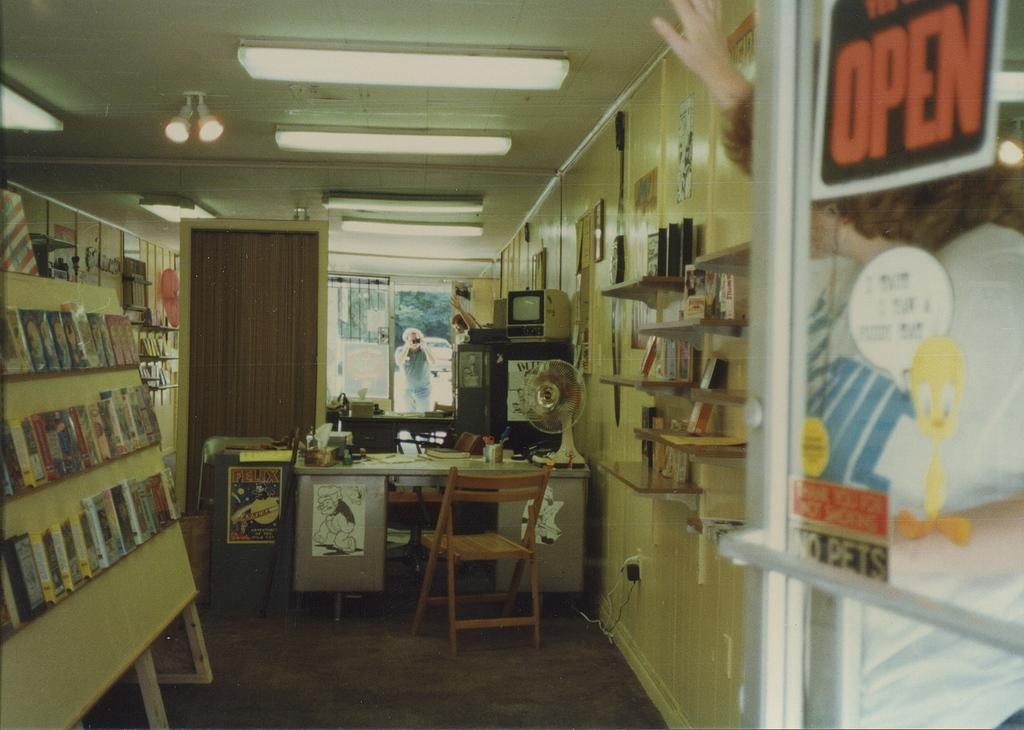Provide a one-sentence caption for the provided image. A sign in a window reads open in orange lettering. 